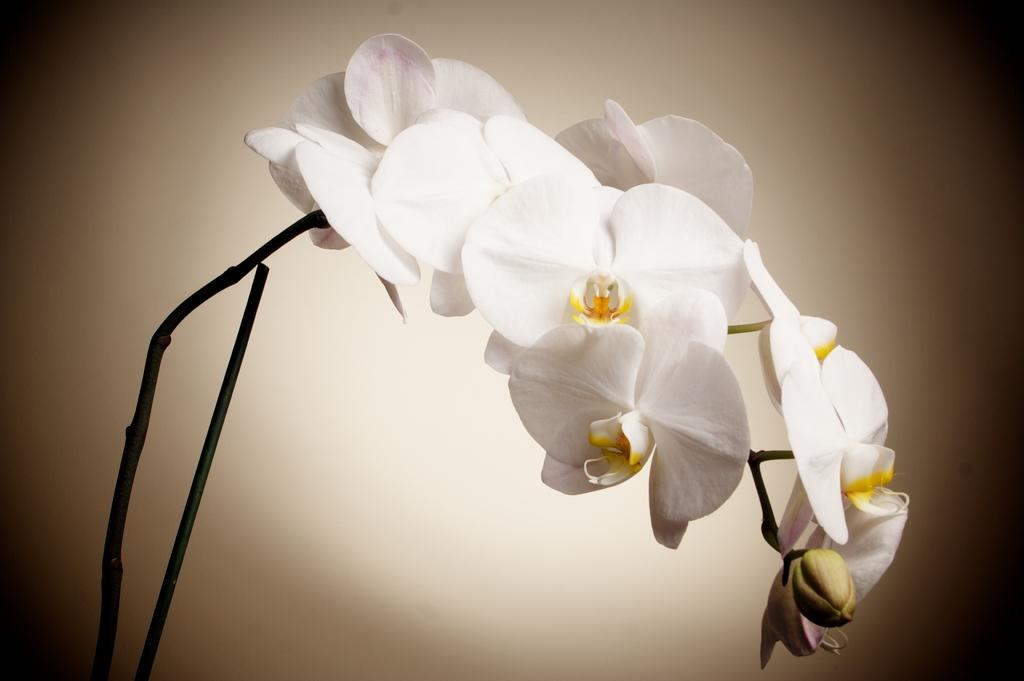What type of flowers can be seen in the image? There are white flowers in the image. Can you describe the stage of growth for one of the flowers? There is a bud in the image, which indicates a flower in the early stages of growth. How are the flowers connected to each other in the image? The flowers are connected by stems, which are truncated towards the bottom of the image. What color is the background of the image? The background of the image is white in color. What type of company is mentioned in the image? There is no mention of a company in the image; it features white flowers with a white background. How many beds are visible in the image? There are no beds present in the image. 